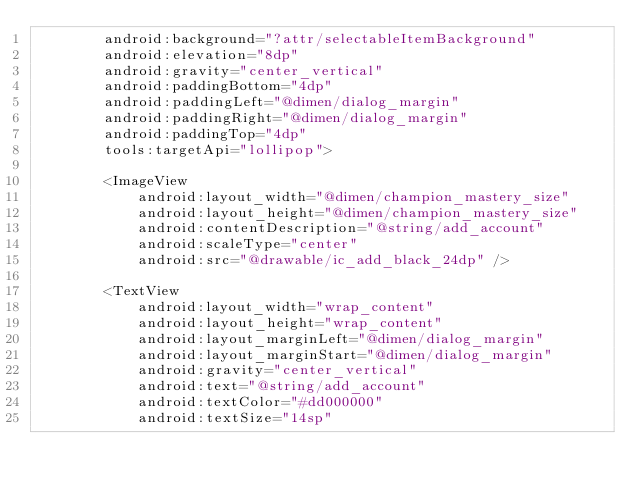Convert code to text. <code><loc_0><loc_0><loc_500><loc_500><_XML_>        android:background="?attr/selectableItemBackground"
        android:elevation="8dp"
        android:gravity="center_vertical"
        android:paddingBottom="4dp"
        android:paddingLeft="@dimen/dialog_margin"
        android:paddingRight="@dimen/dialog_margin"
        android:paddingTop="4dp"
        tools:targetApi="lollipop">

        <ImageView
            android:layout_width="@dimen/champion_mastery_size"
            android:layout_height="@dimen/champion_mastery_size"
            android:contentDescription="@string/add_account"
            android:scaleType="center"
            android:src="@drawable/ic_add_black_24dp" />

        <TextView
            android:layout_width="wrap_content"
            android:layout_height="wrap_content"
            android:layout_marginLeft="@dimen/dialog_margin"
            android:layout_marginStart="@dimen/dialog_margin"
            android:gravity="center_vertical"
            android:text="@string/add_account"
            android:textColor="#dd000000"
            android:textSize="14sp"</code> 